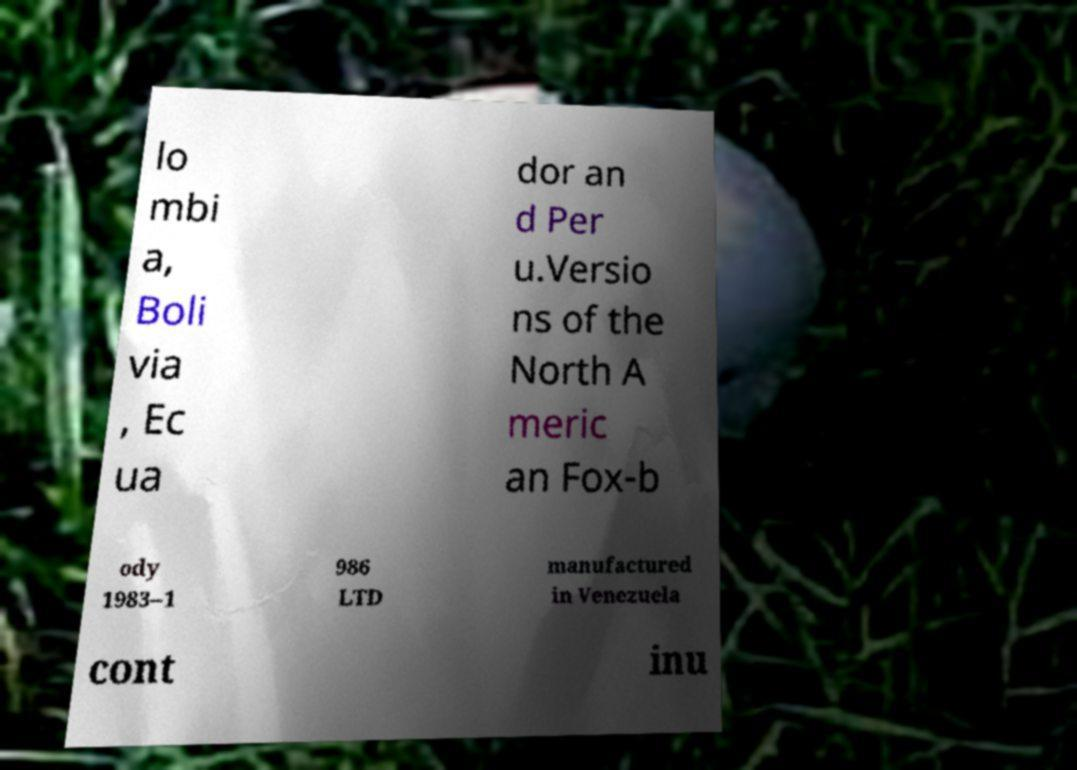Could you extract and type out the text from this image? lo mbi a, Boli via , Ec ua dor an d Per u.Versio ns of the North A meric an Fox-b ody 1983–1 986 LTD manufactured in Venezuela cont inu 